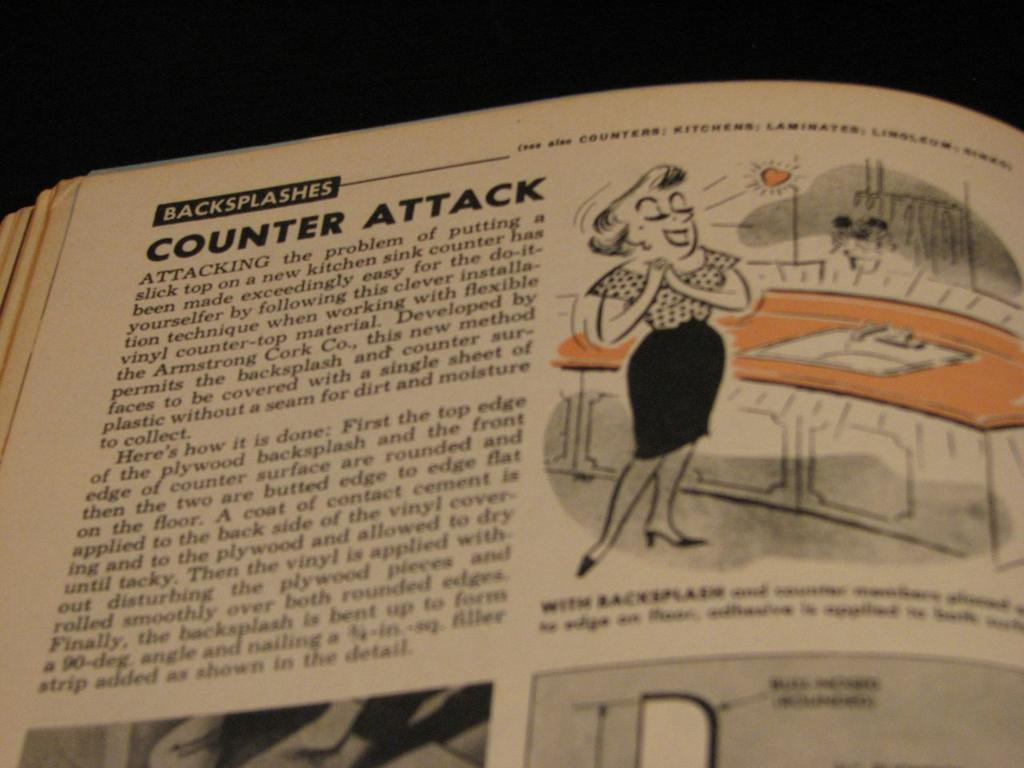What object can be seen in the image? There is a book in the image. Is there anyone present in the image? Yes, there is a person standing in the image. What can be found inside the book? Something is written in the book. How would you describe the lighting in the image? The background of the image is dark. Can you tell me how many bombs are visible in the image? There are no bombs present in the image. What type of machine is being operated by the person in the image? There is no machine being operated by the person in the image. 